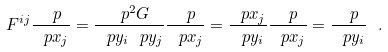Convert formula to latex. <formula><loc_0><loc_0><loc_500><loc_500>F ^ { i j } \frac { \ p } { \ p x _ { j } } = \frac { \ p ^ { 2 } G } { \ p y _ { i } \ p y _ { j } } \frac { \ p } { \ p x _ { j } } = \frac { \ p x _ { j } } { \ p y _ { i } } \frac { \ p } { \ p x _ { j } } = \frac { \ p } { \ p y _ { i } } \ .</formula> 